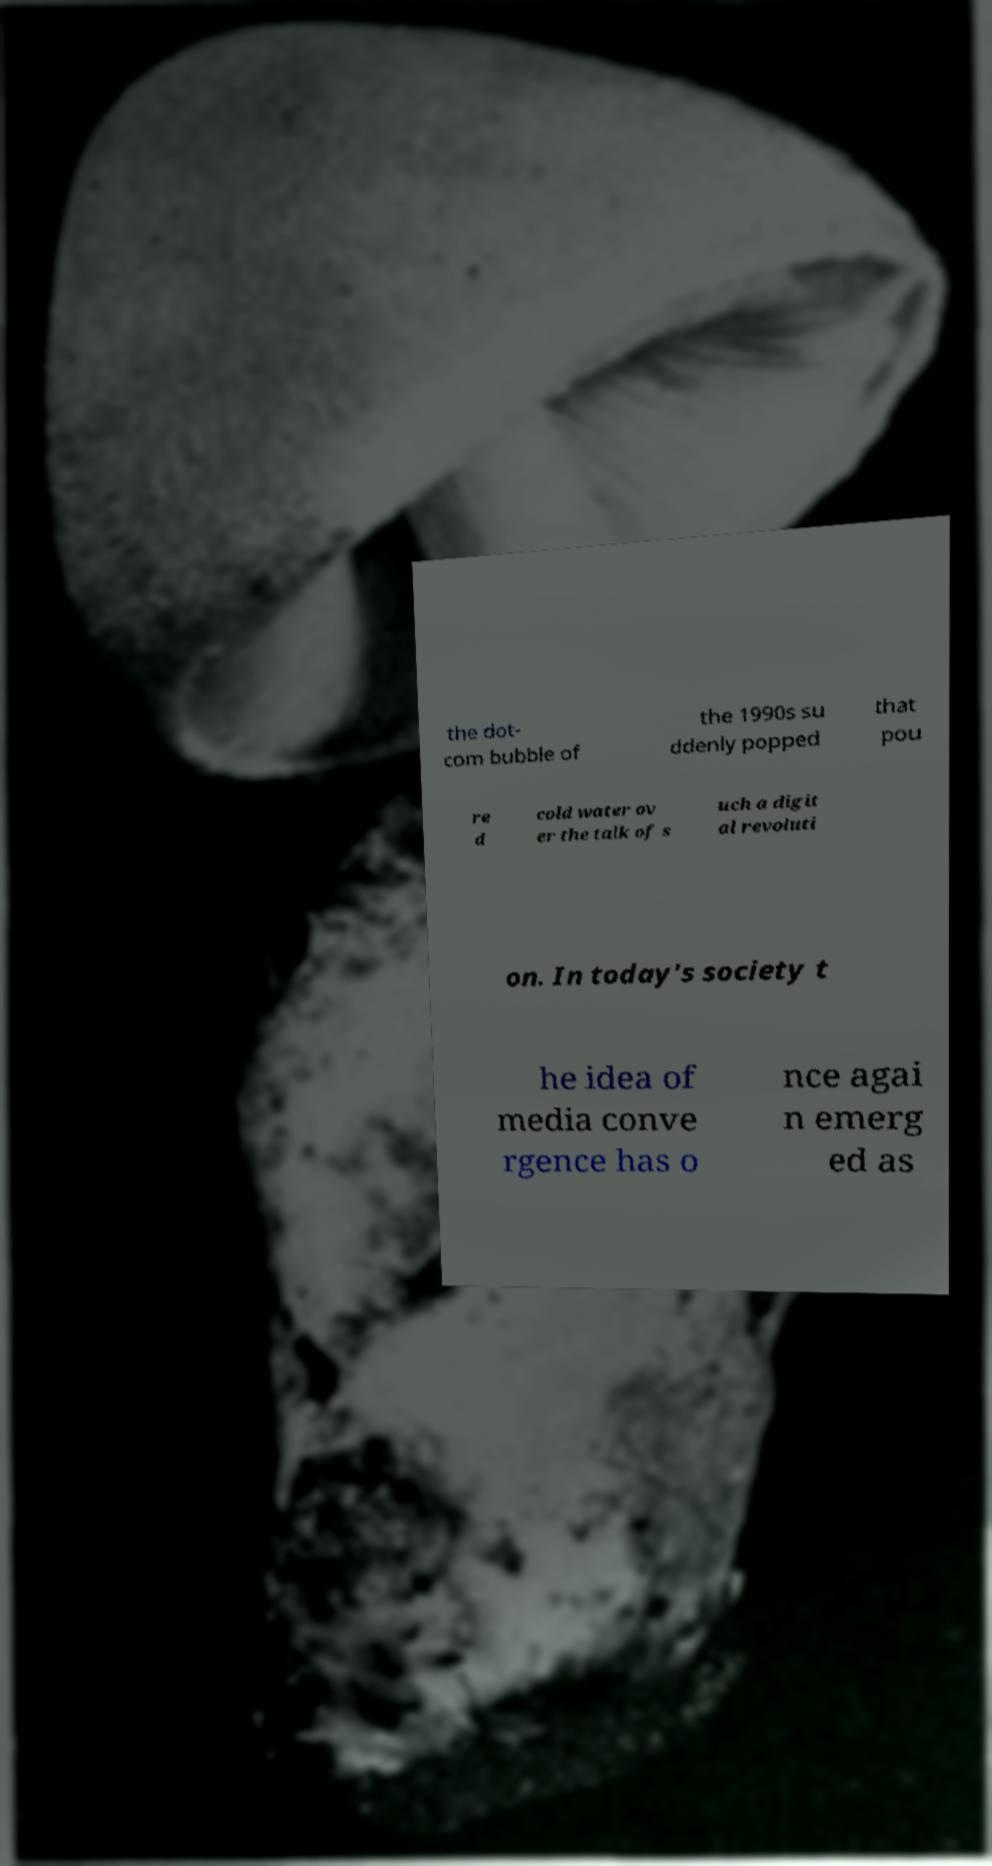Please read and relay the text visible in this image. What does it say? the dot- com bubble of the 1990s su ddenly popped that pou re d cold water ov er the talk of s uch a digit al revoluti on. In today's society t he idea of media conve rgence has o nce agai n emerg ed as 